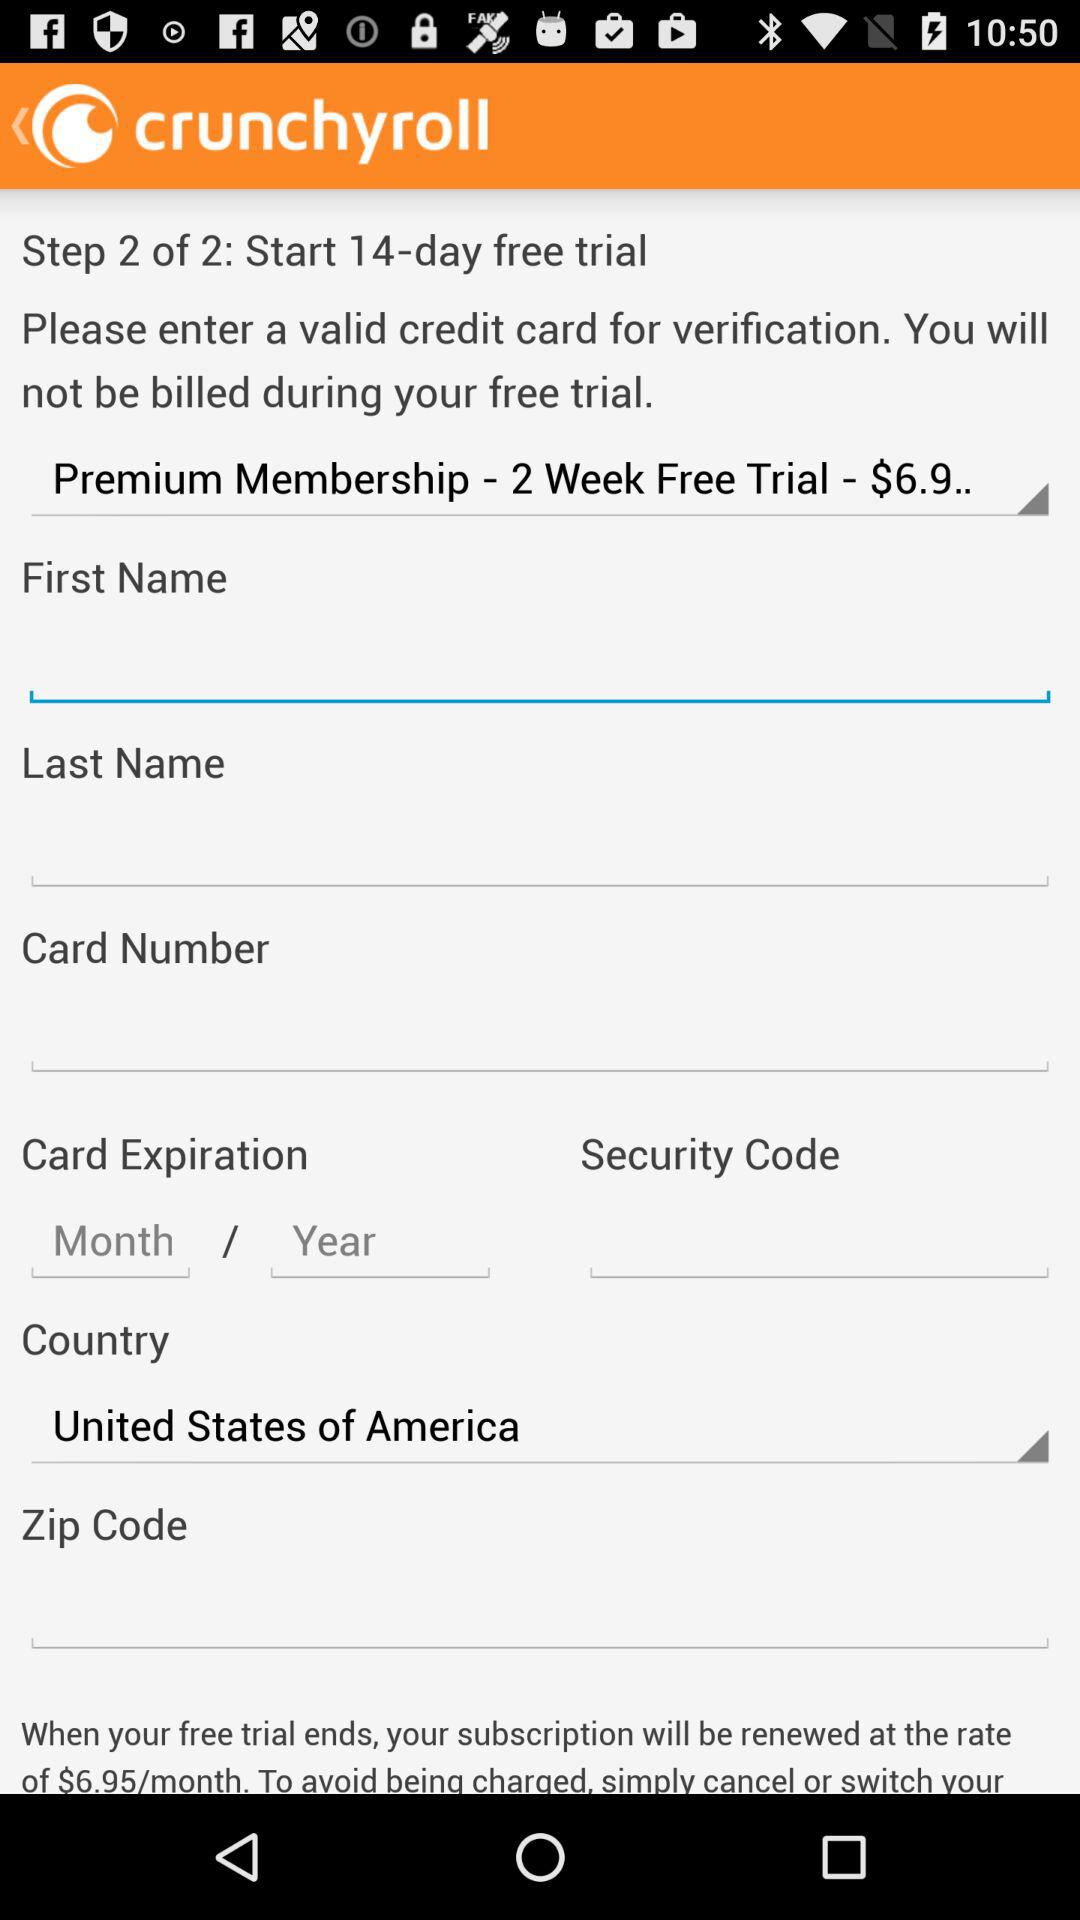Which country is selected? The selected country is the United States of America. 